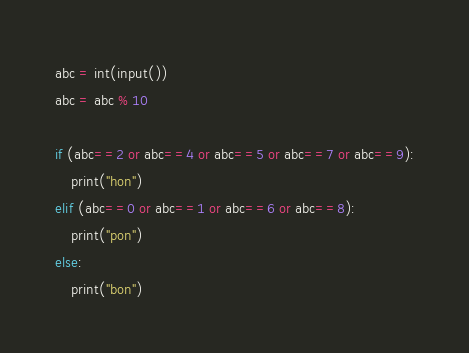<code> <loc_0><loc_0><loc_500><loc_500><_Python_>abc = int(input())
abc = abc % 10

if (abc==2 or abc==4 or abc==5 or abc==7 or abc==9):
    print("hon")
elif (abc==0 or abc==1 or abc==6 or abc==8):
    print("pon")
else:
    print("bon")</code> 